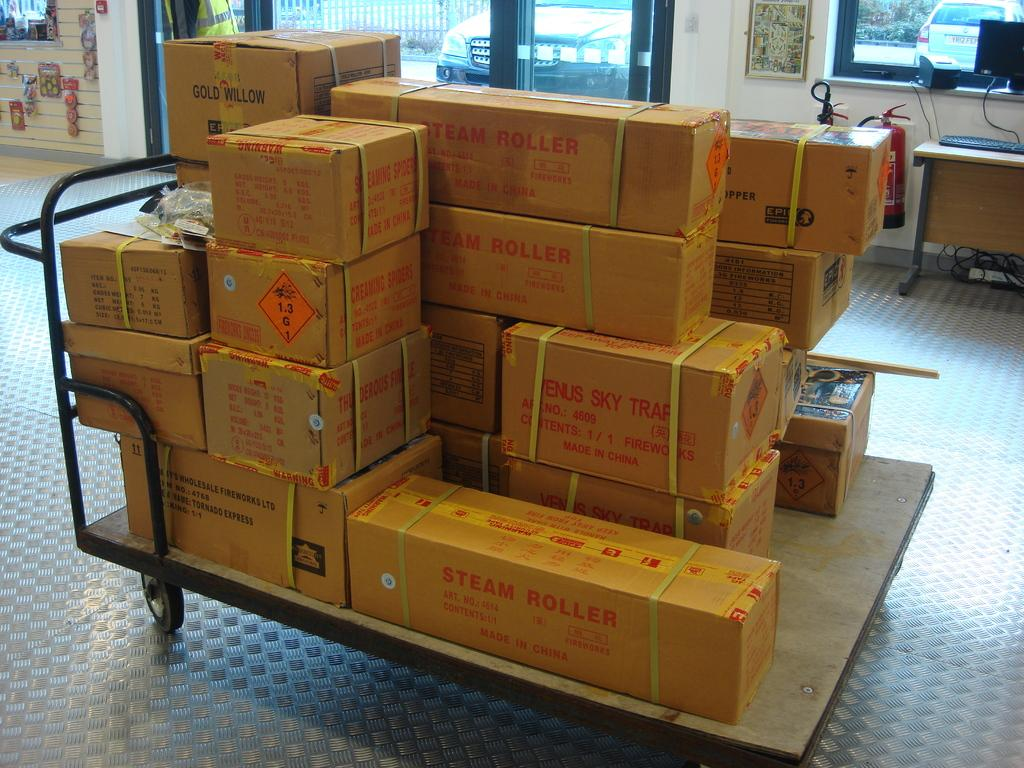<image>
Provide a brief description of the given image. A pile of boxes marked Steam Roller are on a push cart. 